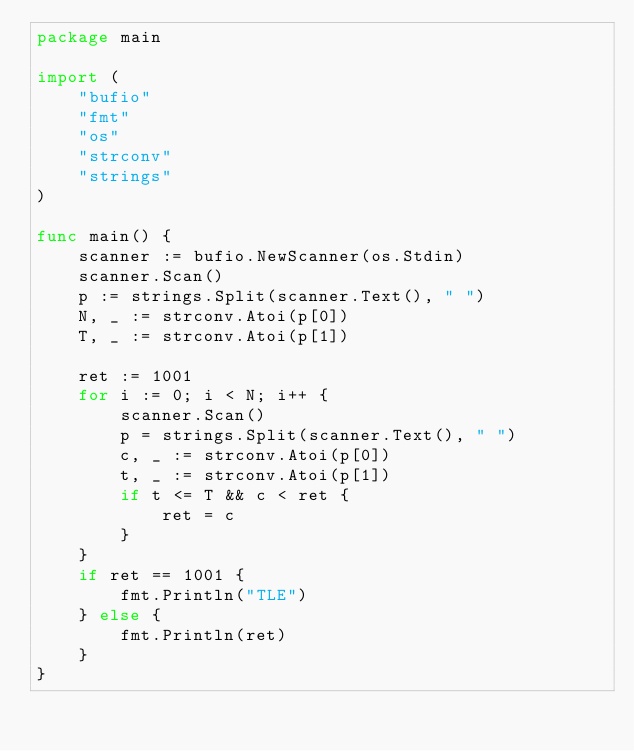<code> <loc_0><loc_0><loc_500><loc_500><_Go_>package main

import (
	"bufio"
	"fmt"
	"os"
	"strconv"
	"strings"
)

func main() {
	scanner := bufio.NewScanner(os.Stdin)
	scanner.Scan()
	p := strings.Split(scanner.Text(), " ")
	N, _ := strconv.Atoi(p[0])
	T, _ := strconv.Atoi(p[1])

	ret := 1001
	for i := 0; i < N; i++ {
		scanner.Scan()
		p = strings.Split(scanner.Text(), " ")
		c, _ := strconv.Atoi(p[0])
		t, _ := strconv.Atoi(p[1])
		if t <= T && c < ret {
			ret = c
		}
	}
	if ret == 1001 {
		fmt.Println("TLE")
	} else {
		fmt.Println(ret)
	}
}</code> 